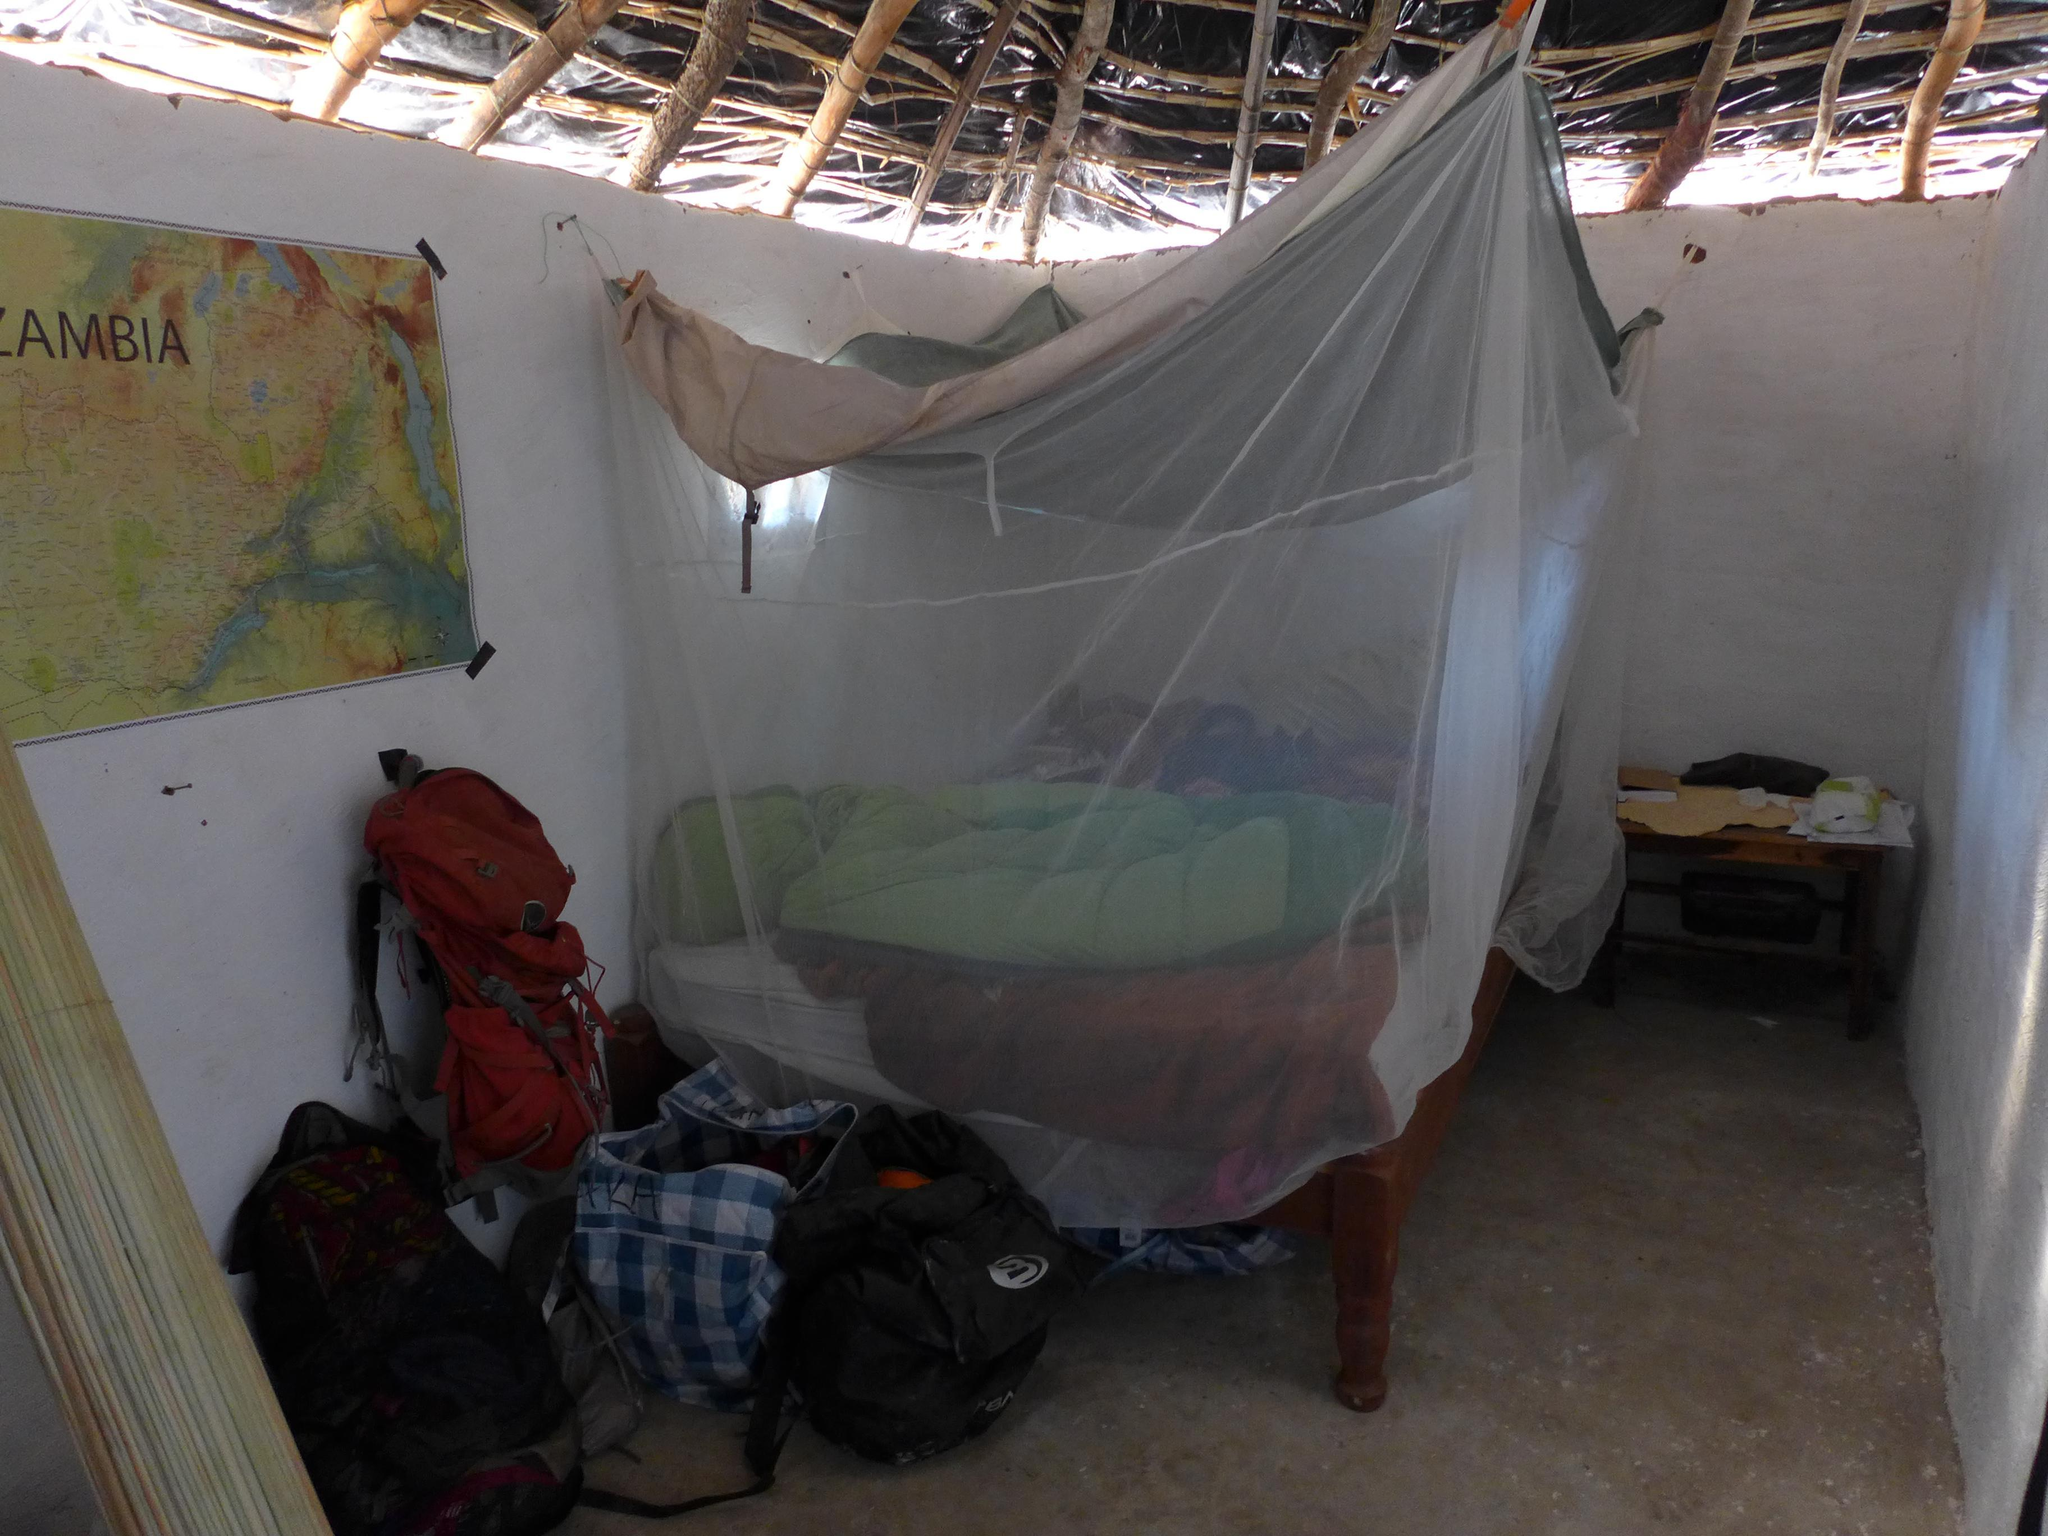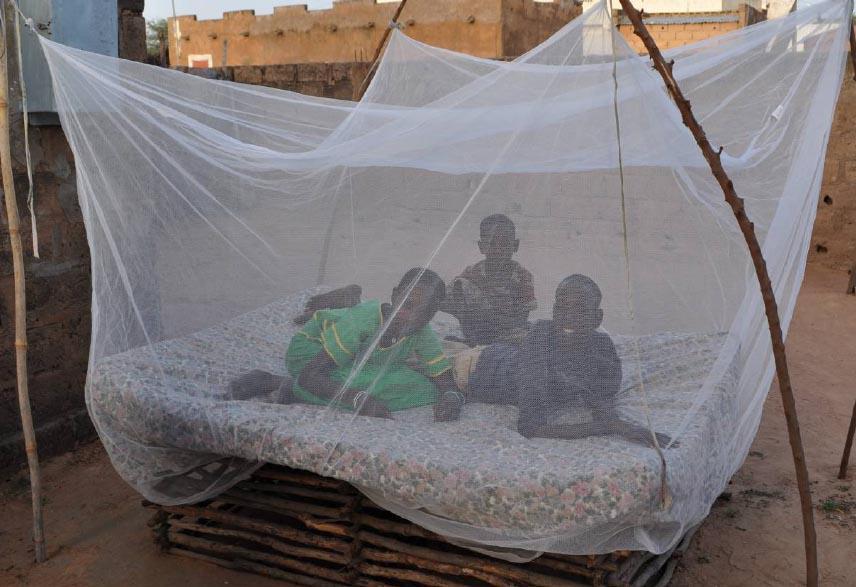The first image is the image on the left, the second image is the image on the right. Considering the images on both sides, is "Two or more humans are visible." valid? Answer yes or no. Yes. 